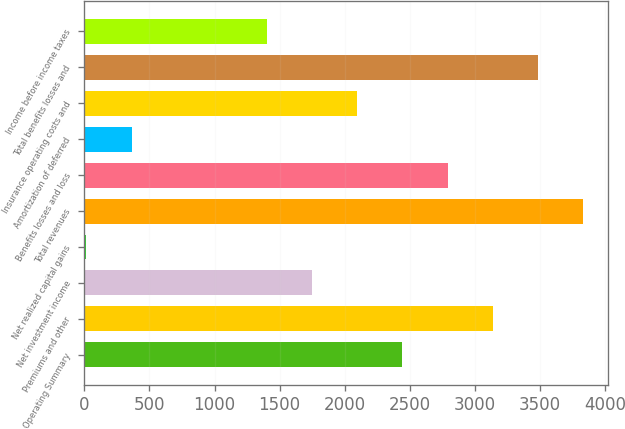<chart> <loc_0><loc_0><loc_500><loc_500><bar_chart><fcel>Operating Summary<fcel>Premiums and other<fcel>Net investment income<fcel>Net realized capital gains<fcel>Total revenues<fcel>Benefits losses and loss<fcel>Amortization of deferred<fcel>Insurance operating costs and<fcel>Total benefits losses and<fcel>Income before income taxes<nl><fcel>2443.3<fcel>3137.1<fcel>1749.5<fcel>15<fcel>3830.9<fcel>2790.2<fcel>361.9<fcel>2096.4<fcel>3484<fcel>1402.6<nl></chart> 